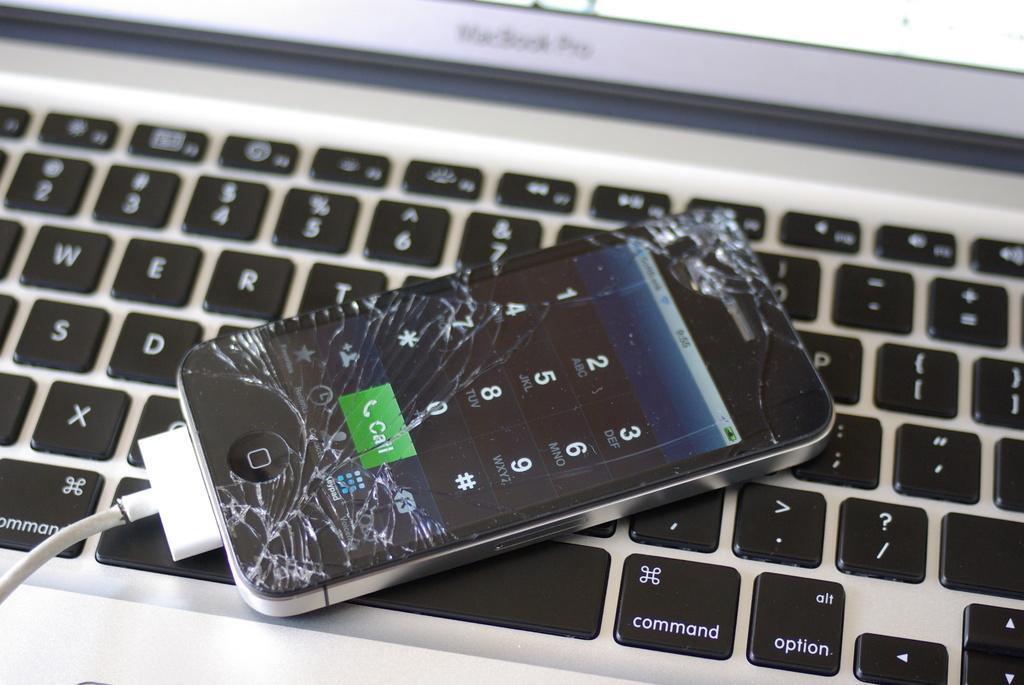<image>
Give a short and clear explanation of the subsequent image. A mobile fine with a smashed screen lies on the keyboard of a Macbook Pro. 